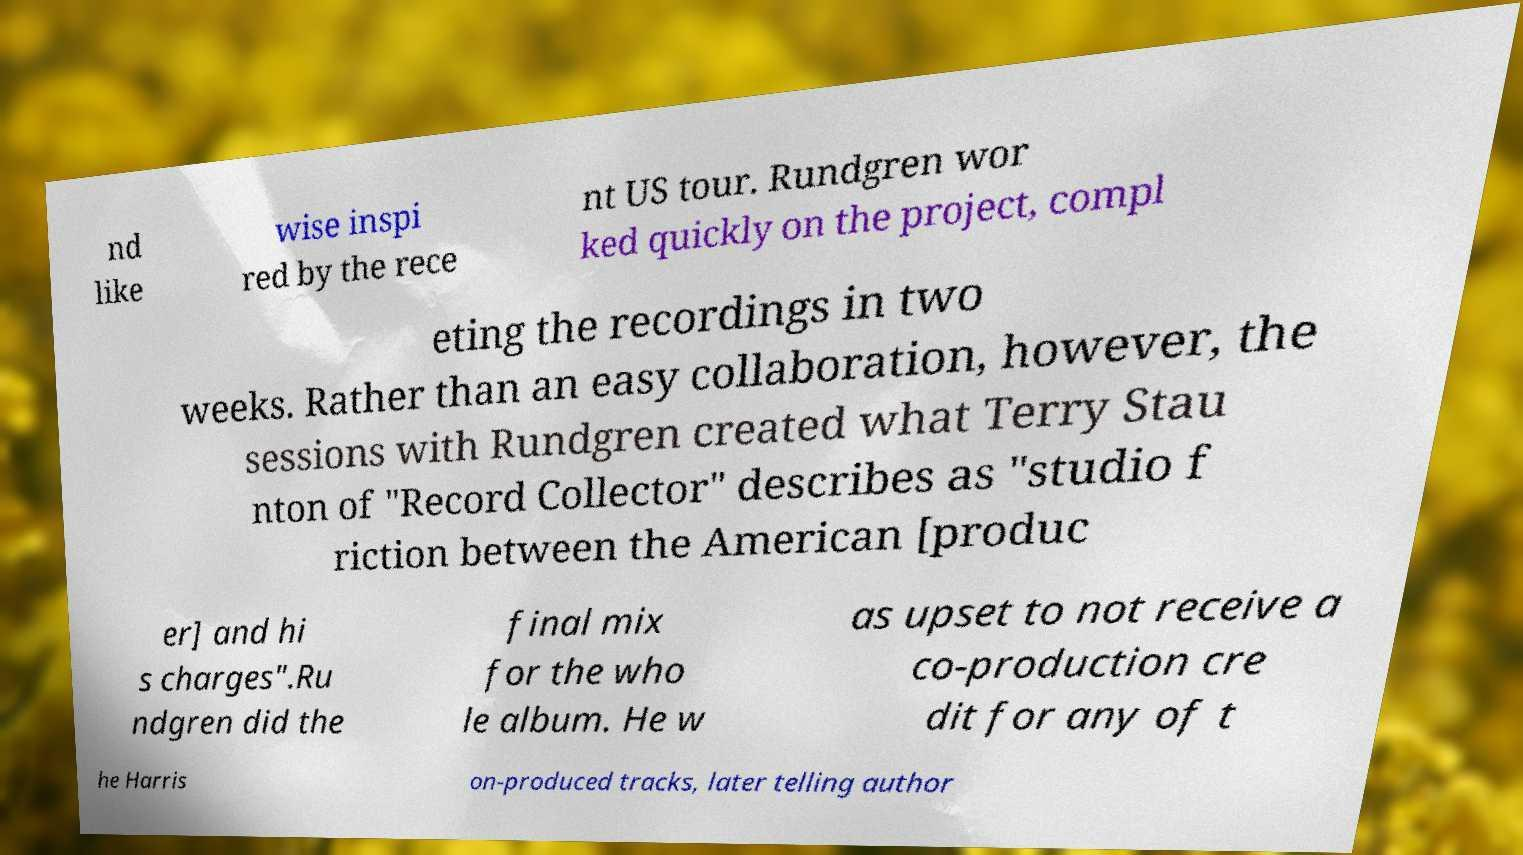Could you extract and type out the text from this image? nd like wise inspi red by the rece nt US tour. Rundgren wor ked quickly on the project, compl eting the recordings in two weeks. Rather than an easy collaboration, however, the sessions with Rundgren created what Terry Stau nton of "Record Collector" describes as "studio f riction between the American [produc er] and hi s charges".Ru ndgren did the final mix for the who le album. He w as upset to not receive a co-production cre dit for any of t he Harris on-produced tracks, later telling author 